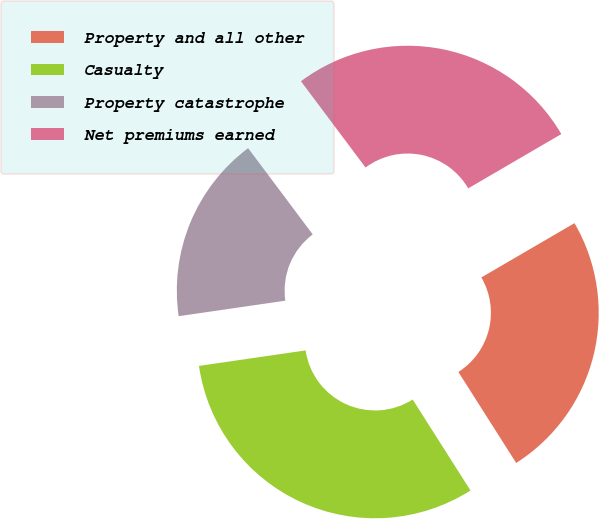Convert chart. <chart><loc_0><loc_0><loc_500><loc_500><pie_chart><fcel>Property and all other<fcel>Casualty<fcel>Property catastrophe<fcel>Net premiums earned<nl><fcel>24.39%<fcel>31.71%<fcel>17.07%<fcel>26.83%<nl></chart> 